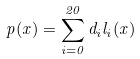<formula> <loc_0><loc_0><loc_500><loc_500>p ( x ) = \sum _ { i = 0 } ^ { 2 0 } d _ { i } l _ { i } ( x )</formula> 